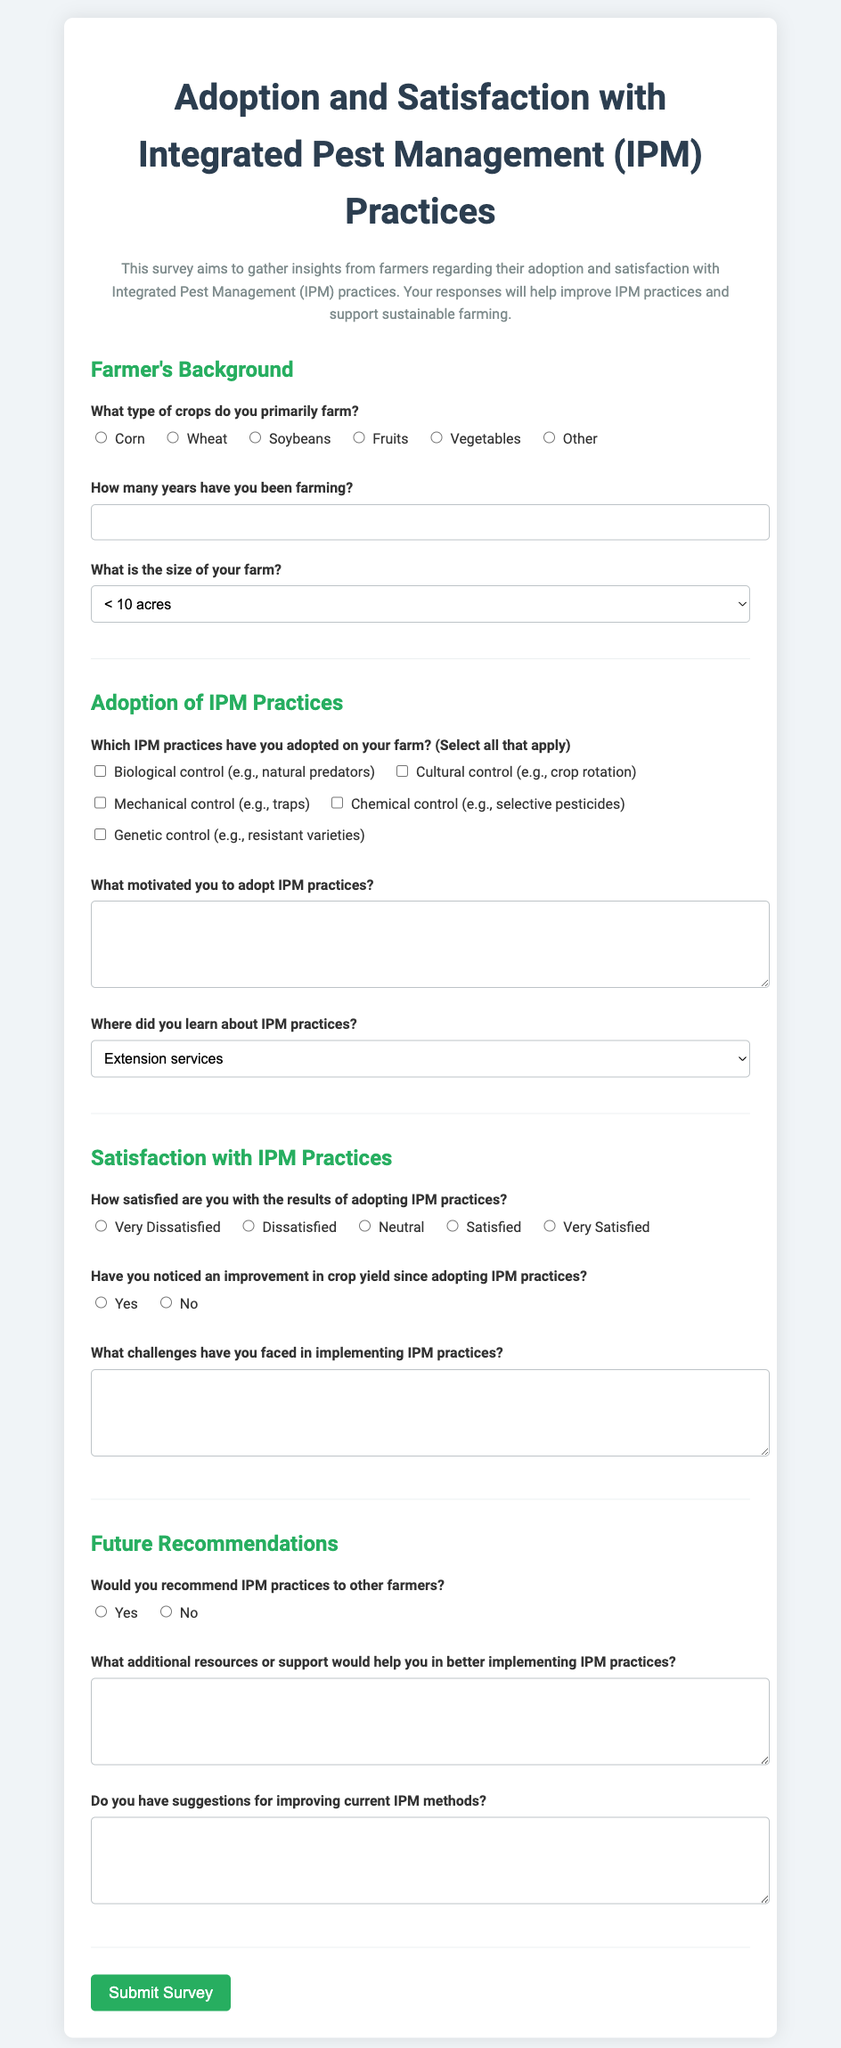What is the title of the survey? The title of the survey is displayed prominently at the top of the document, stating its purpose.
Answer: Adoption and Satisfaction with Integrated Pest Management (IPM) Practices How many sections are in the survey? The survey is divided into four main sections addressing different aspects of IPM practices.
Answer: Four What type of control includes natural predators? This refers specifically to one of the IPM practices outlined in the survey.
Answer: Biological control What is one source where farmers can learn about IPM practices? The document lists several options where farmers can gather information about IPM.
Answer: Extension services How do farmers rate their satisfaction with IPM practices? The satisfaction question allows for a range of responses, reflecting farmers' opinions.
Answer: Very Dissatisfied to Very Satisfied What additional resources could help improve IPM implementation? This question encourages farmers to express specific needs for better IPM practice application.
Answer: Open-ended response What is one challenge farmers might face with IPM practices? This section gathers feedback on potential issues encountered in implementing IPM.
Answer: Open-ended response Would farmers recommend IPM practices to others? This question assesses peer perception of IPM based on the responses of participants in the survey.
Answer: Yes or No 